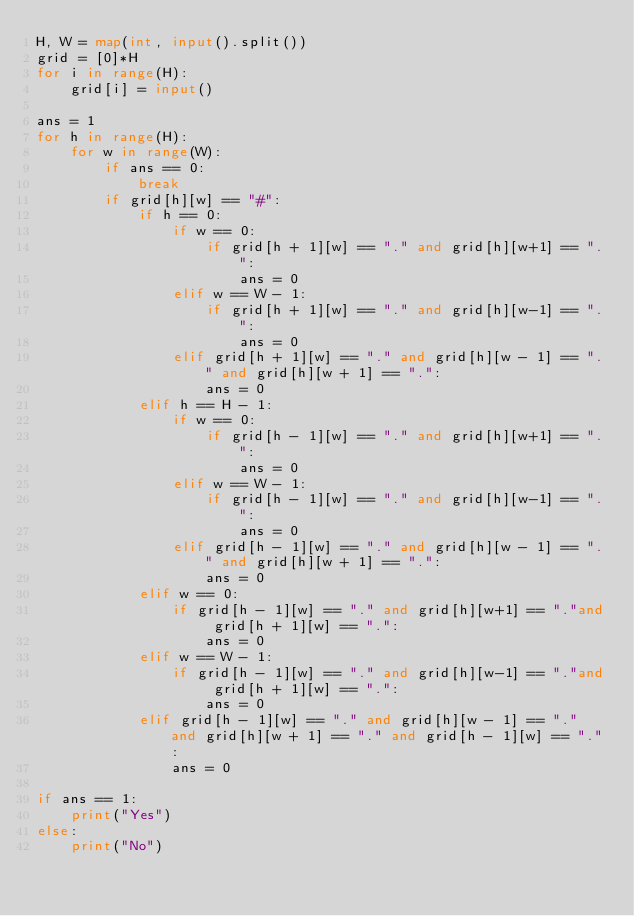<code> <loc_0><loc_0><loc_500><loc_500><_Python_>H, W = map(int, input().split())
grid = [0]*H
for i in range(H):
    grid[i] = input()

ans = 1
for h in range(H):
    for w in range(W):
        if ans == 0:
            break
        if grid[h][w] == "#":
            if h == 0:
                if w == 0:
                    if grid[h + 1][w] == "." and grid[h][w+1] == ".":
                        ans = 0
                elif w == W - 1:
                    if grid[h + 1][w] == "." and grid[h][w-1] == ".":
                        ans = 0
                elif grid[h + 1][w] == "." and grid[h][w - 1] == "." and grid[h][w + 1] == ".":
                    ans = 0
            elif h == H - 1:
                if w == 0:
                    if grid[h - 1][w] == "." and grid[h][w+1] == ".":
                        ans = 0
                elif w == W - 1:
                    if grid[h - 1][w] == "." and grid[h][w-1] == ".":
                        ans = 0
                elif grid[h - 1][w] == "." and grid[h][w - 1] == "." and grid[h][w + 1] == ".":
                    ans = 0
            elif w == 0:
                if grid[h - 1][w] == "." and grid[h][w+1] == "."and grid[h + 1][w] == ".":
                    ans = 0
            elif w == W - 1:
                if grid[h - 1][w] == "." and grid[h][w-1] == "."and grid[h + 1][w] == ".":
                    ans = 0
            elif grid[h - 1][w] == "." and grid[h][w - 1] == "." and grid[h][w + 1] == "." and grid[h - 1][w] == ".":
                ans = 0

if ans == 1:
    print("Yes")
else:
    print("No")
</code> 